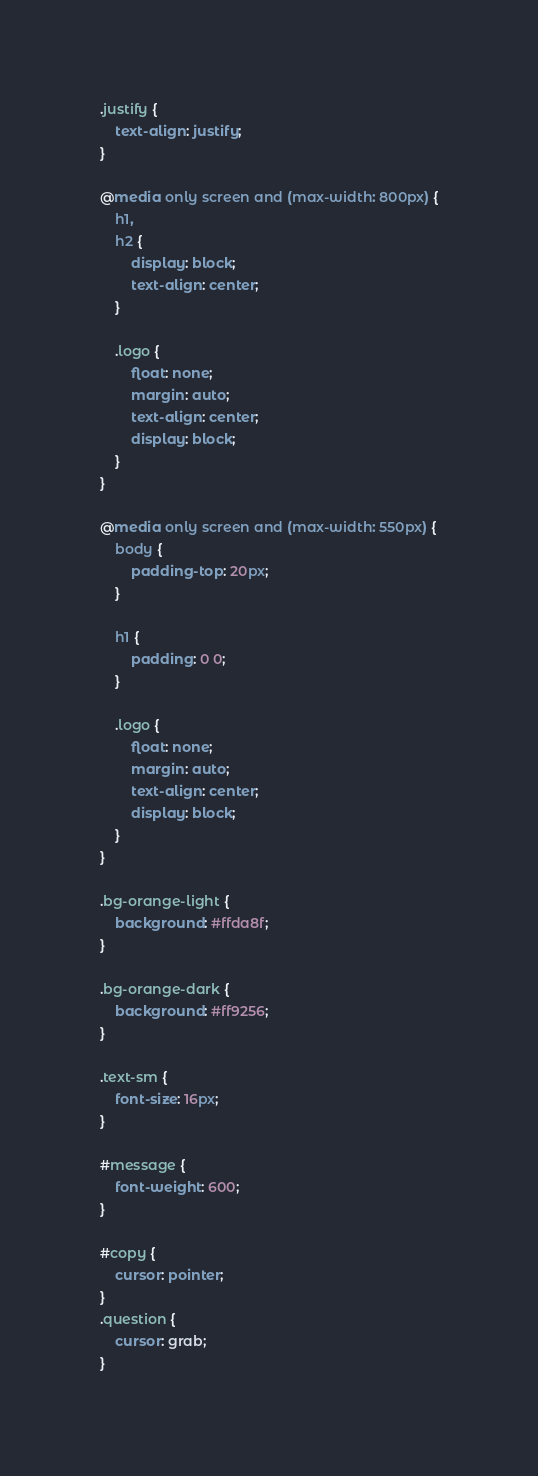Convert code to text. <code><loc_0><loc_0><loc_500><loc_500><_CSS_>
.justify {
	text-align: justify;
}

@media only screen and (max-width: 800px) {
	h1,
	h2 {
		display: block;
		text-align: center;
	}

	.logo {
		float: none;
		margin: auto;
		text-align: center;
		display: block;
	}
}

@media only screen and (max-width: 550px) {
	body {
		padding-top: 20px;
	}

	h1 {
		padding: 0 0;
	}

	.logo {
		float: none;
		margin: auto;
		text-align: center;
		display: block;
	}
}

.bg-orange-light {
	background: #ffda8f;
}

.bg-orange-dark {
	background: #ff9256;
}

.text-sm {
	font-size: 16px;
}

#message {
	font-weight: 600;
}

#copy {
	cursor: pointer;
}
.question {
	cursor: grab;
}
</code> 